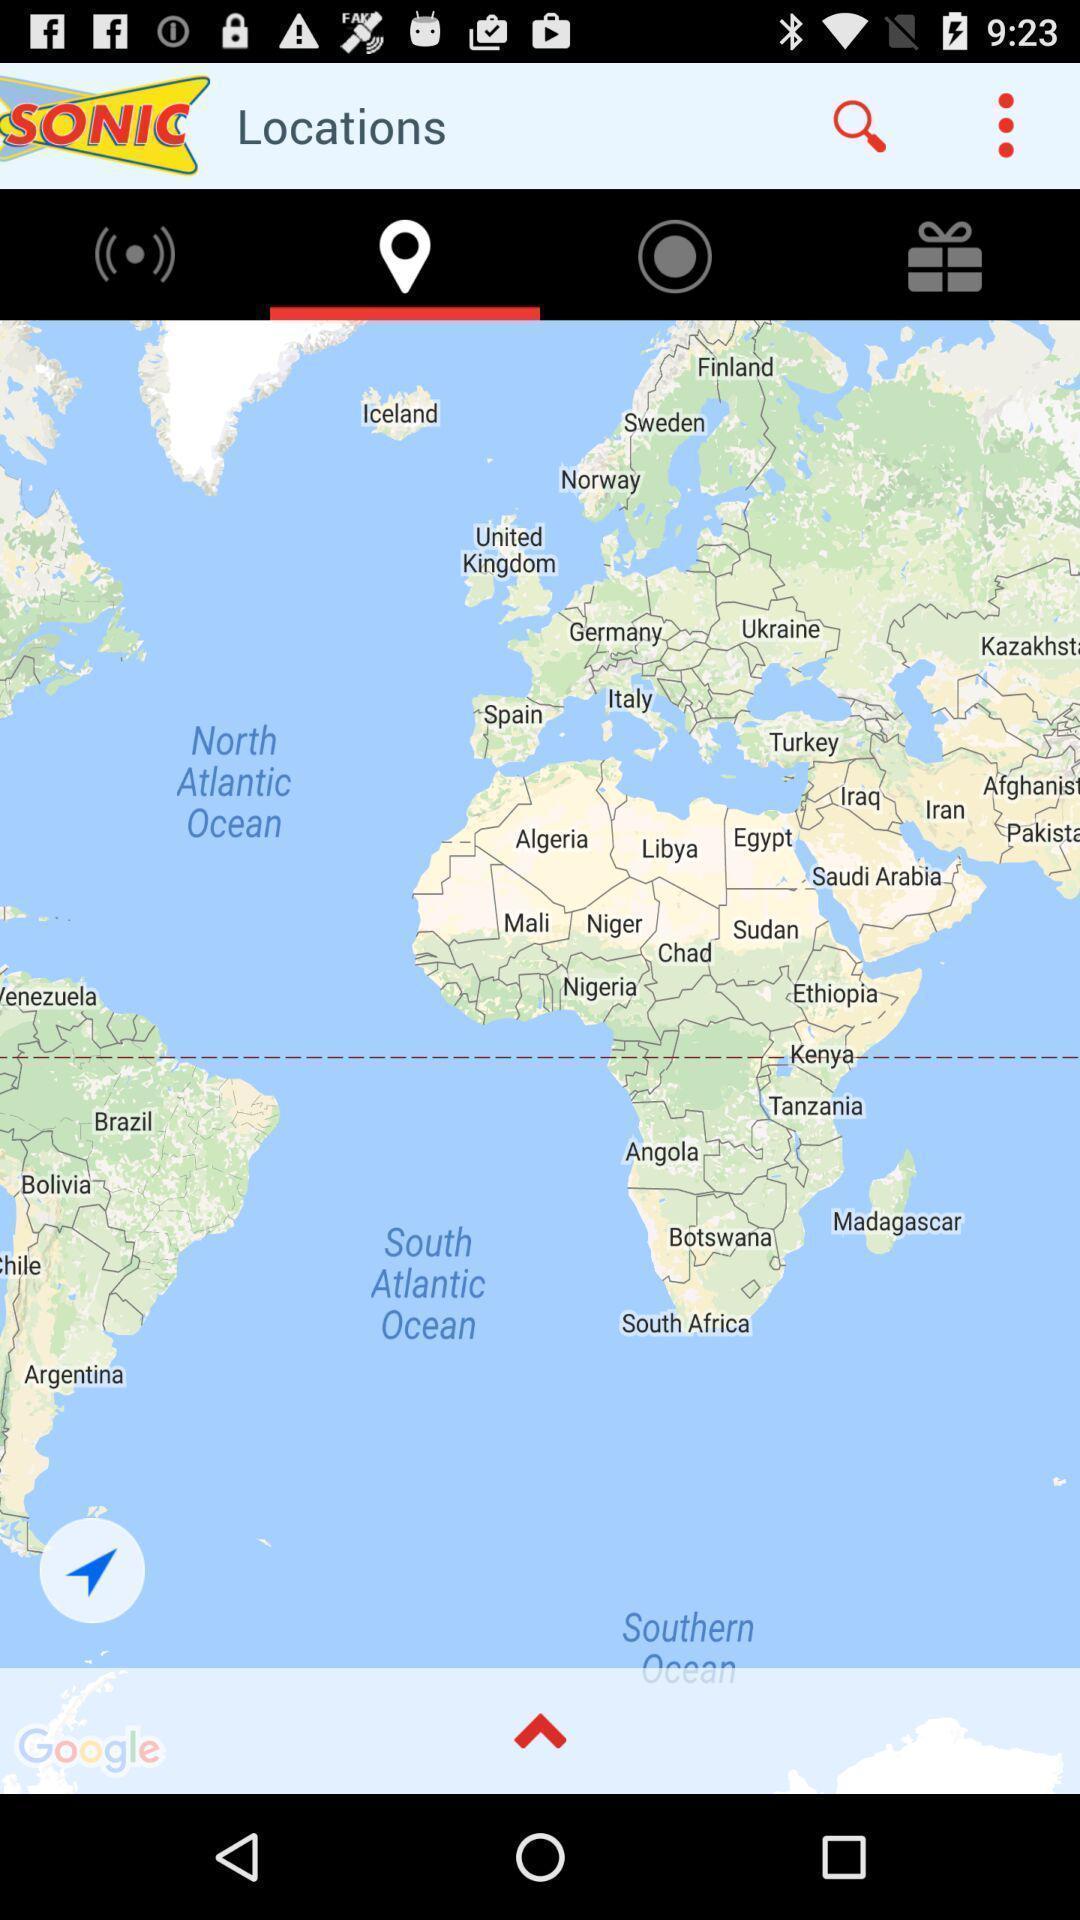Give me a summary of this screen capture. Showing location for address in a map. 